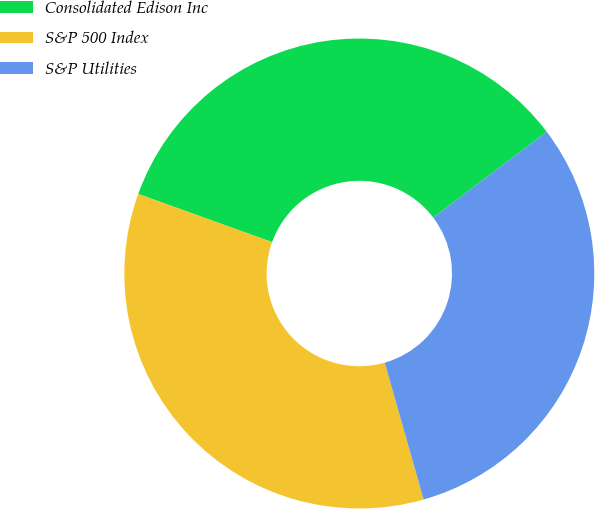Convert chart. <chart><loc_0><loc_0><loc_500><loc_500><pie_chart><fcel>Consolidated Edison Inc<fcel>S&P 500 Index<fcel>S&P Utilities<nl><fcel>34.2%<fcel>34.91%<fcel>30.89%<nl></chart> 